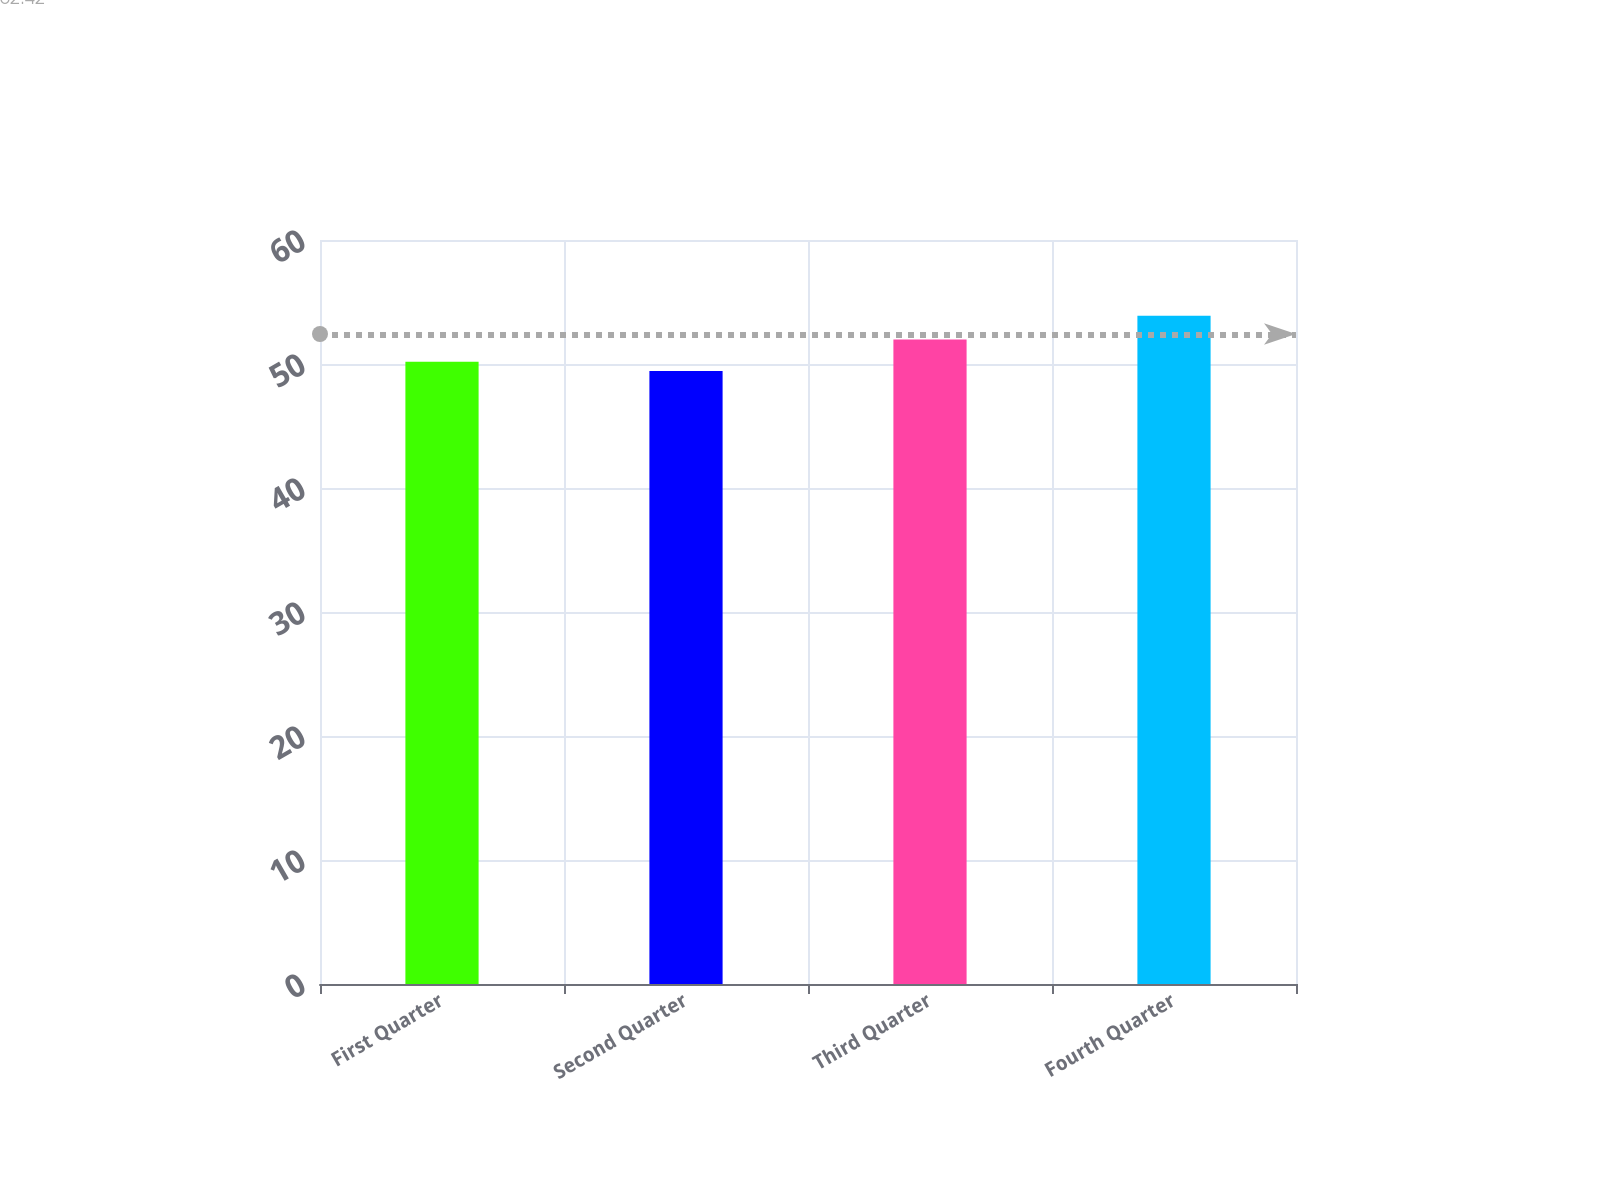Convert chart to OTSL. <chart><loc_0><loc_0><loc_500><loc_500><bar_chart><fcel>First Quarter<fcel>Second Quarter<fcel>Third Quarter<fcel>Fourth Quarter<nl><fcel>50.19<fcel>49.44<fcel>51.98<fcel>53.9<nl></chart> 